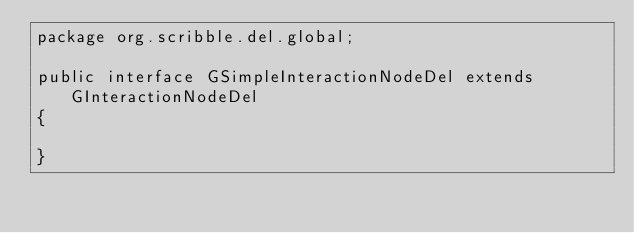<code> <loc_0><loc_0><loc_500><loc_500><_Java_>package org.scribble.del.global;

public interface GSimpleInteractionNodeDel extends GInteractionNodeDel
{

}
</code> 